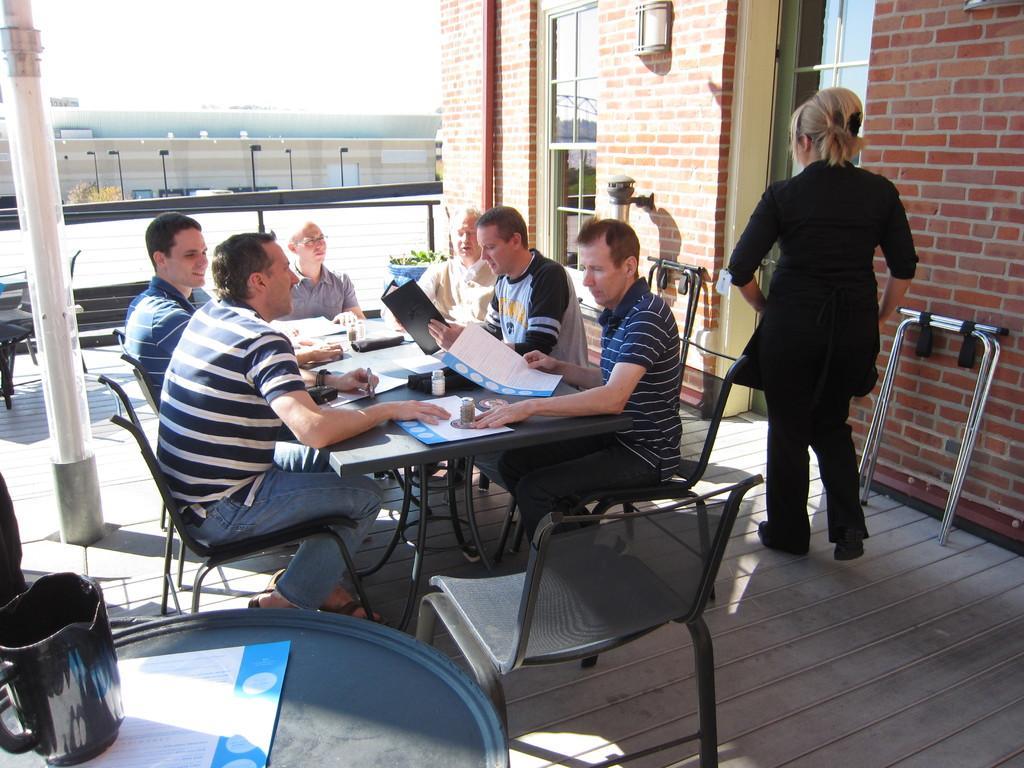Please provide a concise description of this image. In this image, group of people are sat on the black chair. In the middle, there is a black color table. On top of the table, few items are placed. On right side, there is a woman wearing a black dress and pant. Left side we can see a pillar. And table at the bottom. On top of it, we can see a jug. On right side we can see a brick wall. The background, we can see a outside view,pillars and poles. 